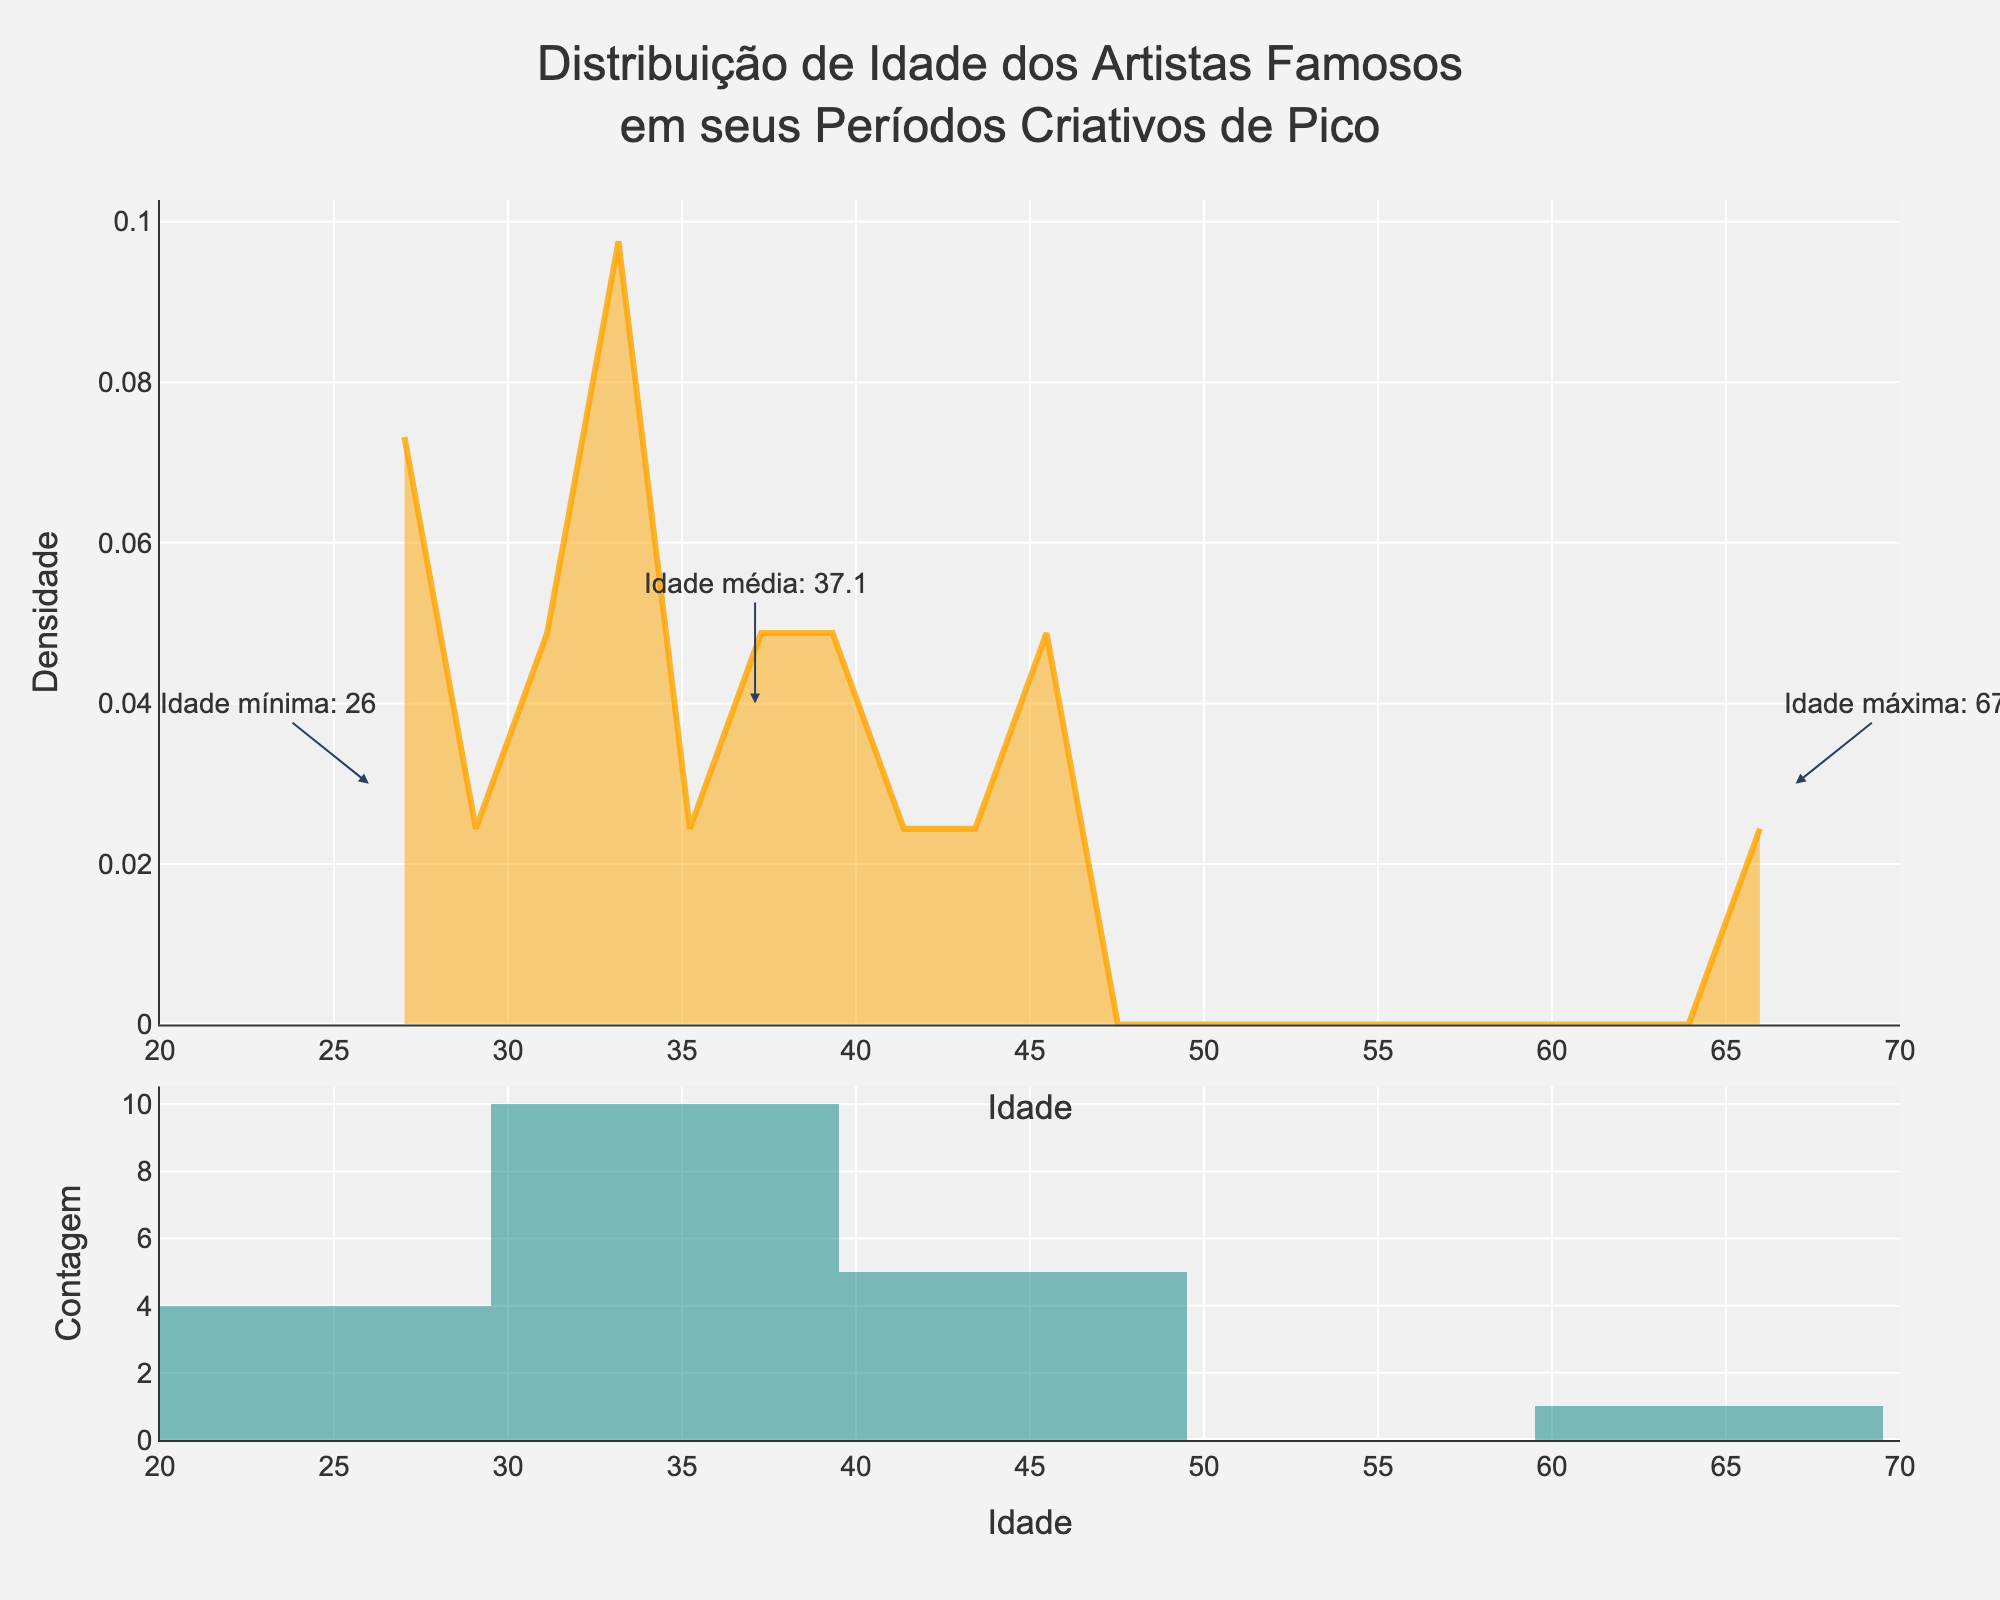What's the title of the figure? The title is located at the top of the figure in a larger font size. It reads "Distribuição de Idade dos Artistas Famosos em seus Períodos Criativos de Pico".
Answer: Distribuição de Idade dos Artistas Famosos em seus Períodos Criativos de Pico What are the axes labeled? The x-axis is labeled "Idade," and the y-axis is labeled "Densidade" for the KDE plot. In the histogram plot, the x-axis is also labeled "Idade," and the y-axis is labeled "Contagem." These labels are typically found along the respective axes.
Answer: Idade and Densidade (KDE); Idade and Contagem (Histogram) What is the maximum age of artists during their peak creative periods? The maximum age is highlighted with an annotation in the figure. The annotation text reads "Idade máxima: 67," which refers to the age of Paul Cézanne.
Answer: 67 What does the color of the KDE line represent? The color of the KDE line, which is an orange shade, represents the age density distribution of artists at their peak creative periods.
Answer: Age density distribution How many artists' data points are represented in the histogram? By counting the number of data points in the given data, which lists the ages of the artists, we find there are 20 artists represented.
Answer: 20 What is the most common age range for artists' peak creative periods based on the histogram? By examining the bars in the histogram, the age range with the highest bar likely represents the most common age range. In this figure, the peak appears around 30-40 years.
Answer: 30-40 years What is the mean age of artists during their peak creative periods? The mean age is shown by an annotation in the figure. It states, "Idade média: 36.7," indicating the average age.
Answer: 36.7 Compare the ages of Leonardo da Vinci and Pablo Picasso. Which artist was younger during their peak creative period? By comparing the given ages, Leonardo da Vinci (38) and Pablo Picasso (26), we find that Pablo Picasso was younger during his peak creative period.
Answer: Pablo Picasso What is the density value at the mean age of 36.7? The density value can be approximated by locating the mean age of 36.7 on the x-axis of the KDE plot and checking the corresponding density value on the y-axis. It appears to be around 0.04.
Answer: 0.04 